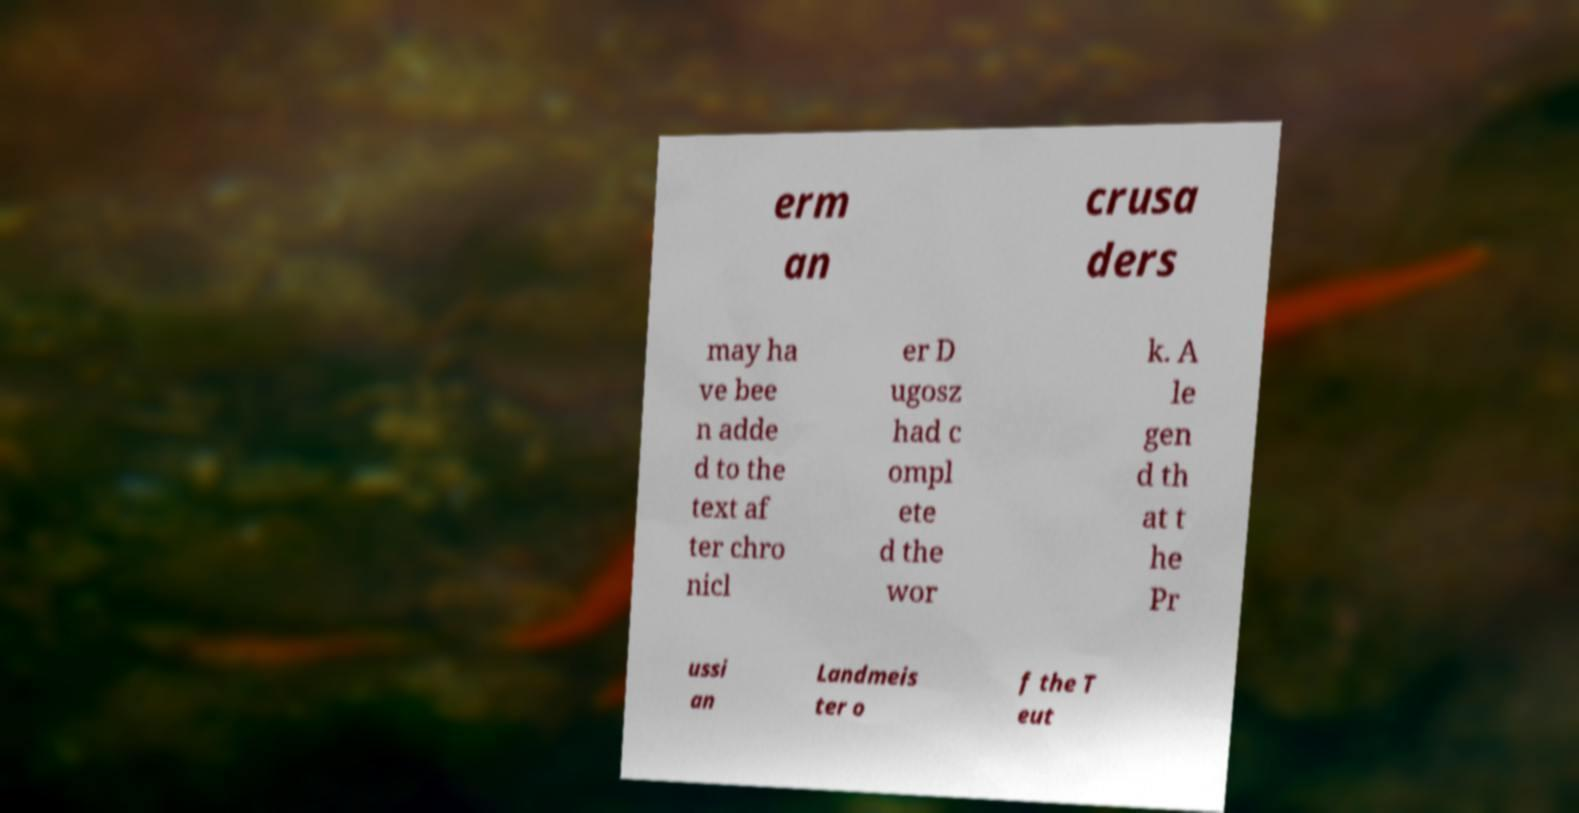There's text embedded in this image that I need extracted. Can you transcribe it verbatim? erm an crusa ders may ha ve bee n adde d to the text af ter chro nicl er D ugosz had c ompl ete d the wor k. A le gen d th at t he Pr ussi an Landmeis ter o f the T eut 